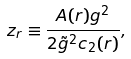<formula> <loc_0><loc_0><loc_500><loc_500>z _ { r } \equiv \frac { A ( r ) g ^ { 2 } } { 2 \tilde { g } ^ { 2 } c _ { 2 } ( r ) } ,</formula> 